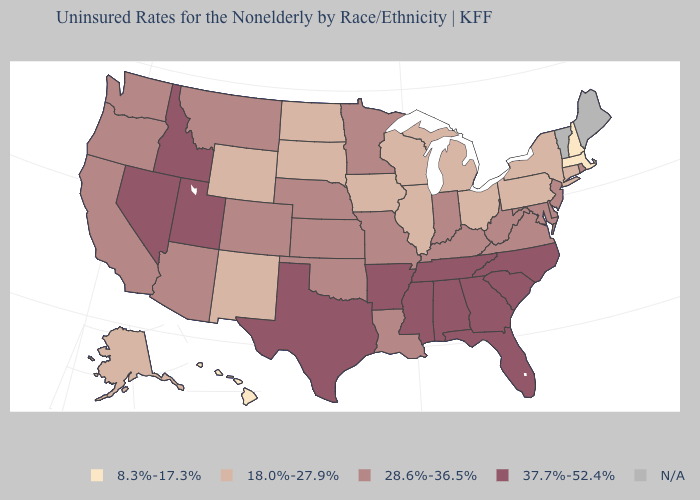Does the first symbol in the legend represent the smallest category?
Concise answer only. Yes. Name the states that have a value in the range 37.7%-52.4%?
Be succinct. Alabama, Arkansas, Florida, Georgia, Idaho, Mississippi, Nevada, North Carolina, South Carolina, Tennessee, Texas, Utah. Among the states that border Nevada , which have the highest value?
Be succinct. Idaho, Utah. What is the highest value in the USA?
Answer briefly. 37.7%-52.4%. Name the states that have a value in the range 18.0%-27.9%?
Write a very short answer. Alaska, Connecticut, Illinois, Iowa, Michigan, New Mexico, New York, North Dakota, Ohio, Pennsylvania, South Dakota, Wisconsin, Wyoming. What is the value of Delaware?
Give a very brief answer. 28.6%-36.5%. Name the states that have a value in the range 18.0%-27.9%?
Short answer required. Alaska, Connecticut, Illinois, Iowa, Michigan, New Mexico, New York, North Dakota, Ohio, Pennsylvania, South Dakota, Wisconsin, Wyoming. Does the map have missing data?
Quick response, please. Yes. What is the highest value in the USA?
Quick response, please. 37.7%-52.4%. Name the states that have a value in the range 8.3%-17.3%?
Concise answer only. Hawaii, Massachusetts, New Hampshire. Does Hawaii have the lowest value in the West?
Be succinct. Yes. Does the map have missing data?
Quick response, please. Yes. What is the lowest value in the MidWest?
Write a very short answer. 18.0%-27.9%. Among the states that border North Dakota , which have the lowest value?
Quick response, please. South Dakota. 